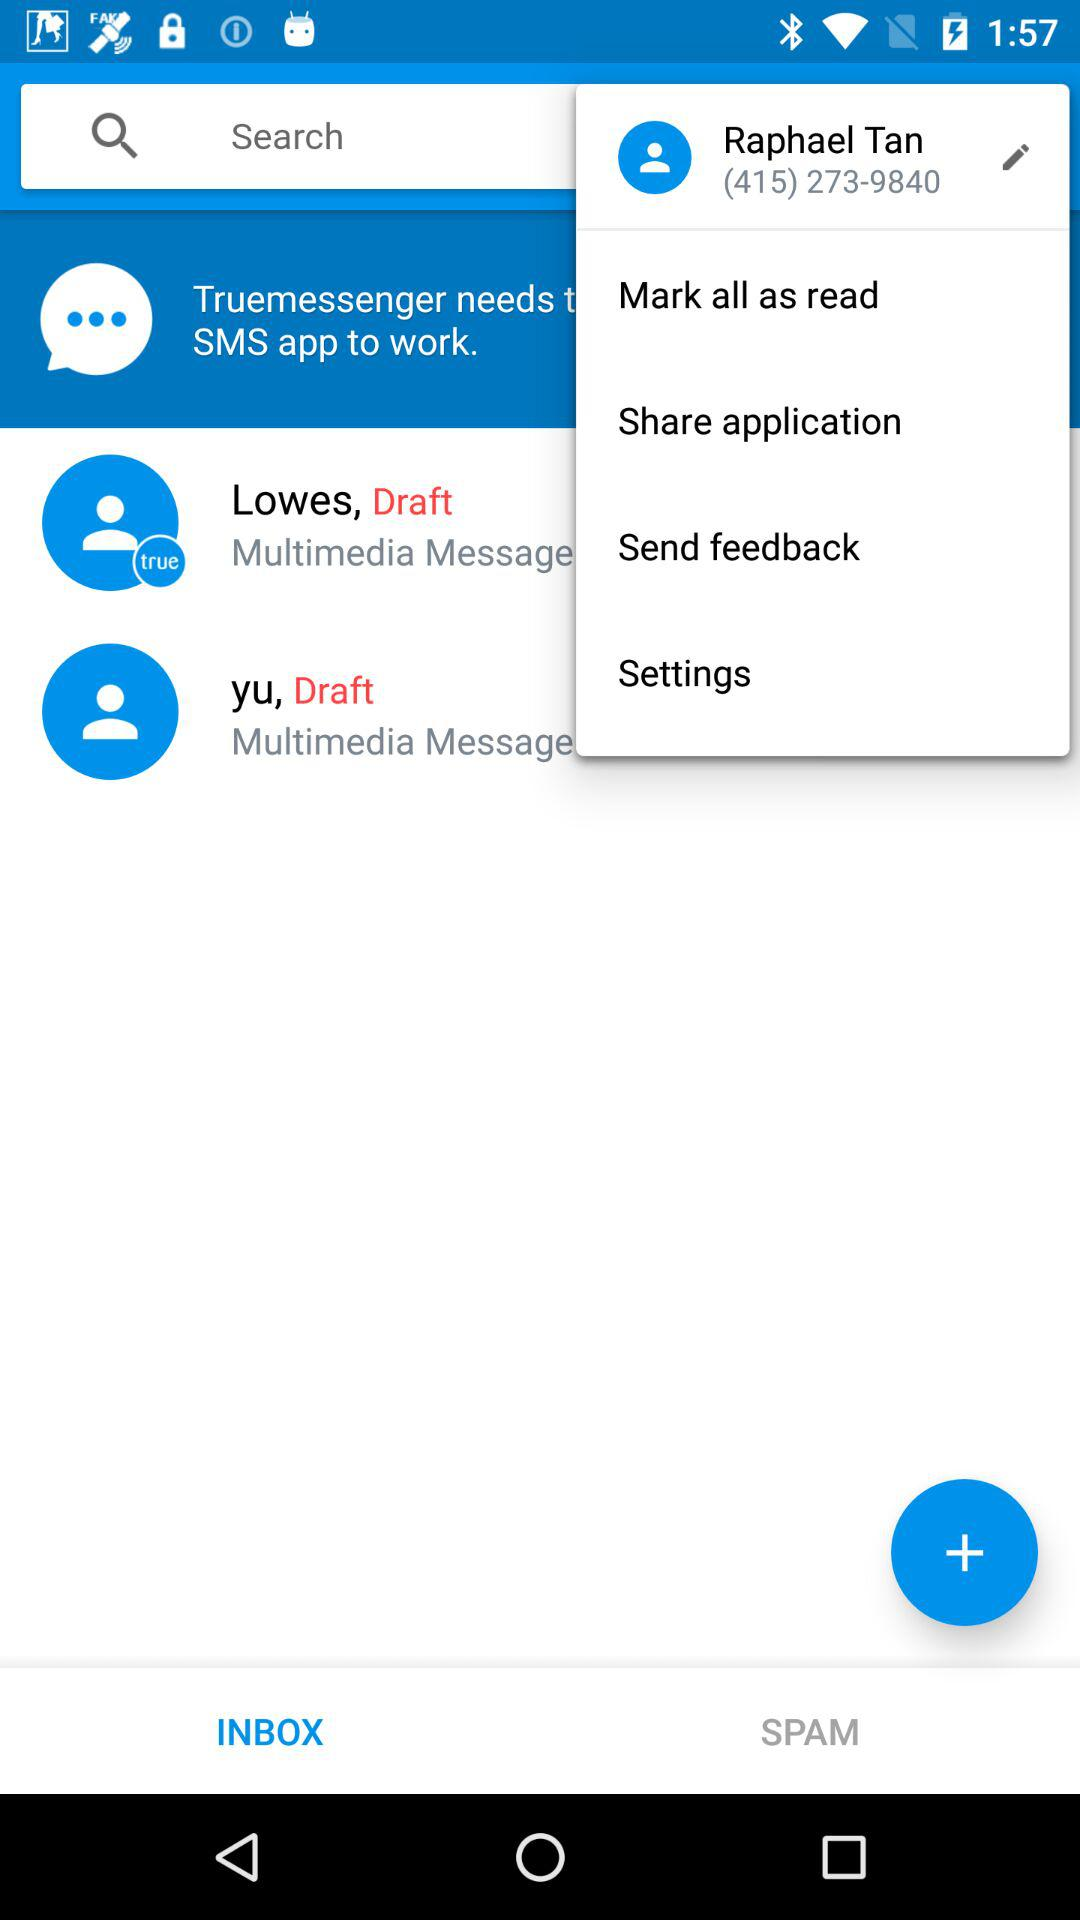How many notifications are there in "Settings"?
When the provided information is insufficient, respond with <no answer>. <no answer> 